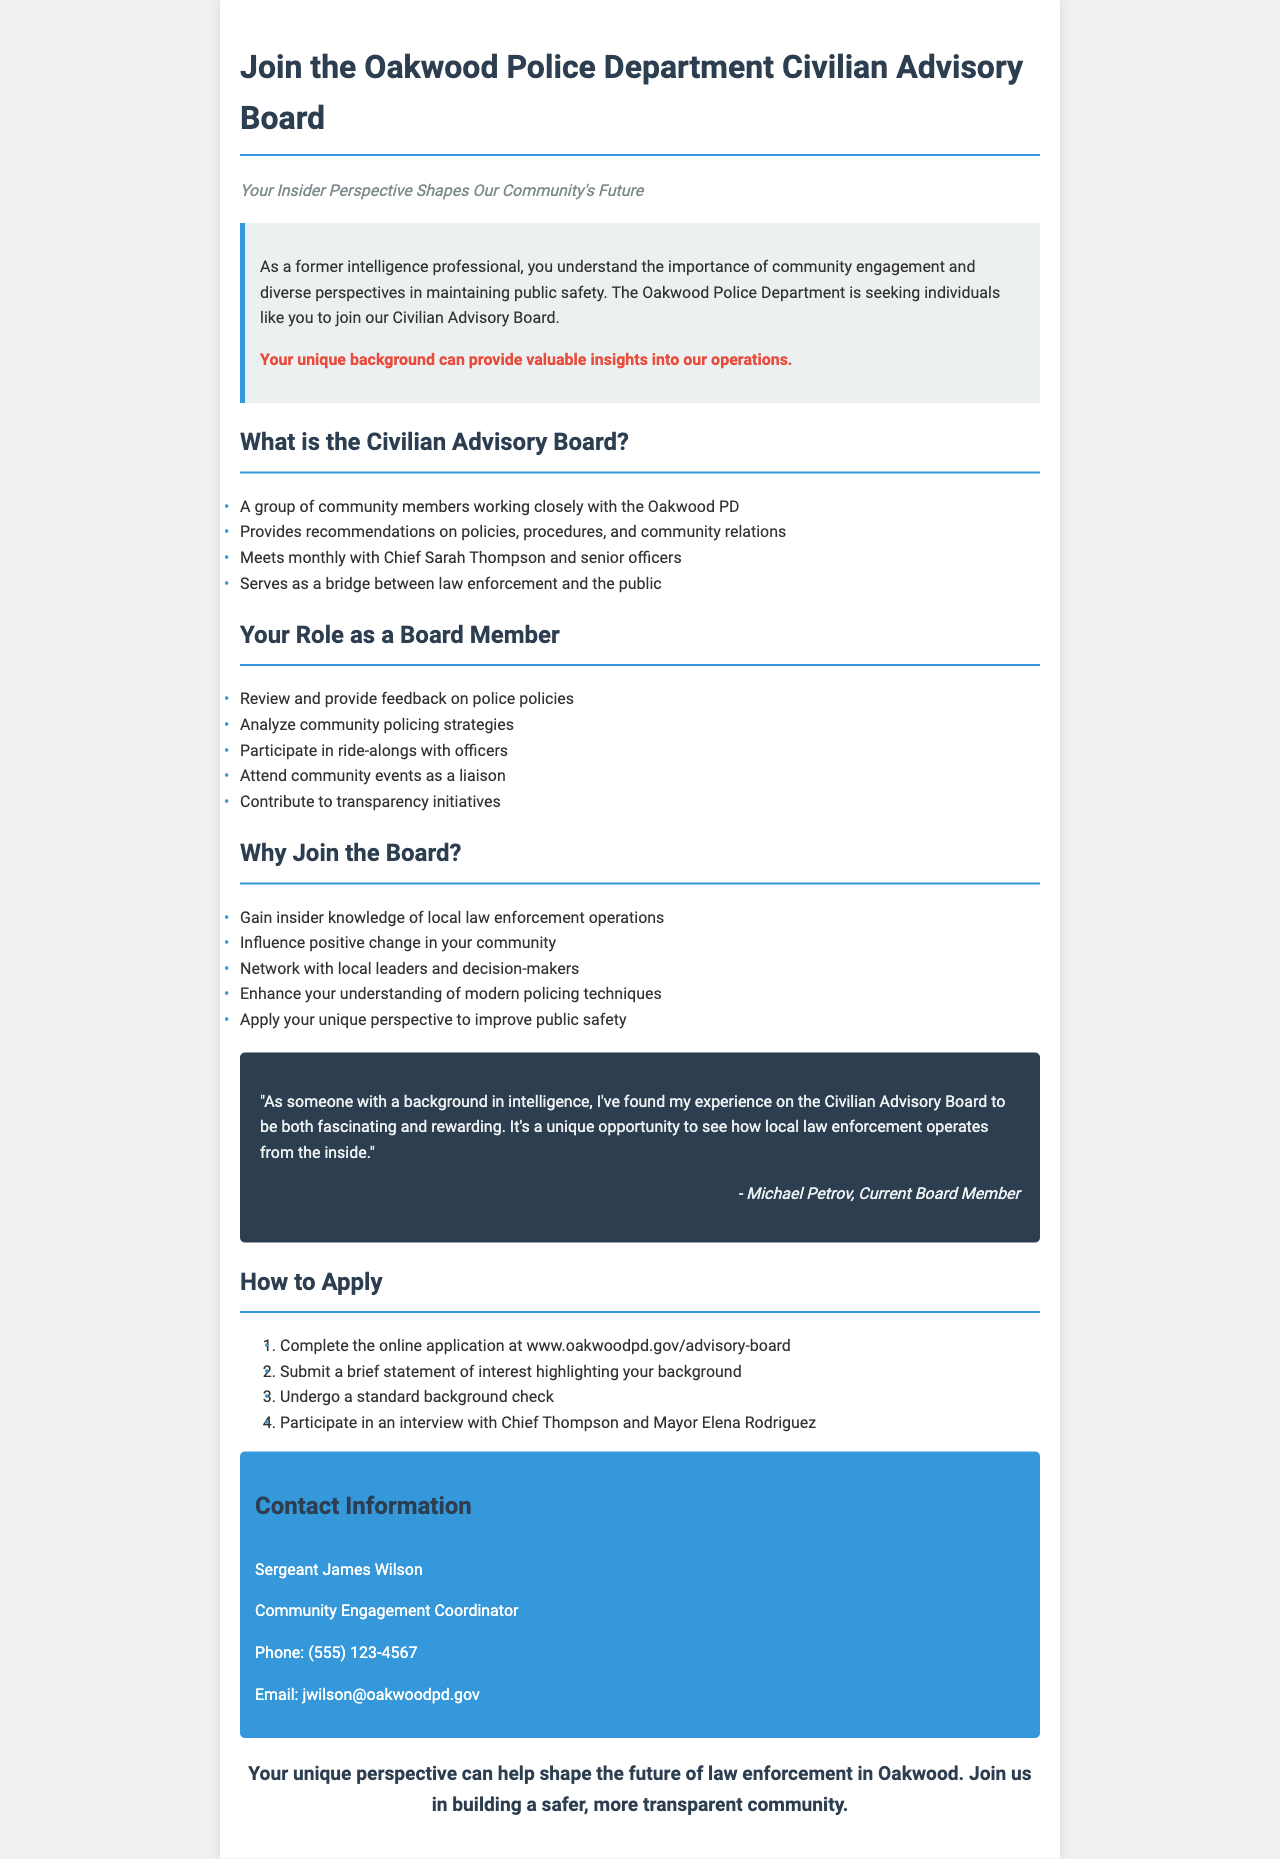What is the title of the brochure? The title of the brochure is mentioned at the top of the document.
Answer: Join the Oakwood Police Department Civilian Advisory Board Who is the Community Engagement Coordinator? The document specifies the contact person for community engagement.
Answer: Sergeant James Wilson How often does the Civilian Advisory Board meet? Frequency of meetings is outlined in the description of the board.
Answer: Monthly What is one of the key responsibilities of a board member? The document lists various responsibilities that board members have.
Answer: Review and provide feedback on police policies What is one benefit of joining the board? A section highlighting the advantages of board membership indicates benefits.
Answer: Gain insider knowledge of local law enforcement operations What is the first step in the application process? The document includes a list of steps for the application process.
Answer: Complete the online application at www.oakwoodpd.gov/advisory-board Why should someone with an intelligence background consider joining the board? The introduction emphasizes the value of unique perspectives in the role.
Answer: Your unique background can provide valuable insights into our operations What is the quote from the testimonial? The testimonial section features a specific statement from a current board member.
Answer: "As someone with a background in intelligence, I've found my experience on the Civilian Advisory Board to be both fascinating and rewarding." 